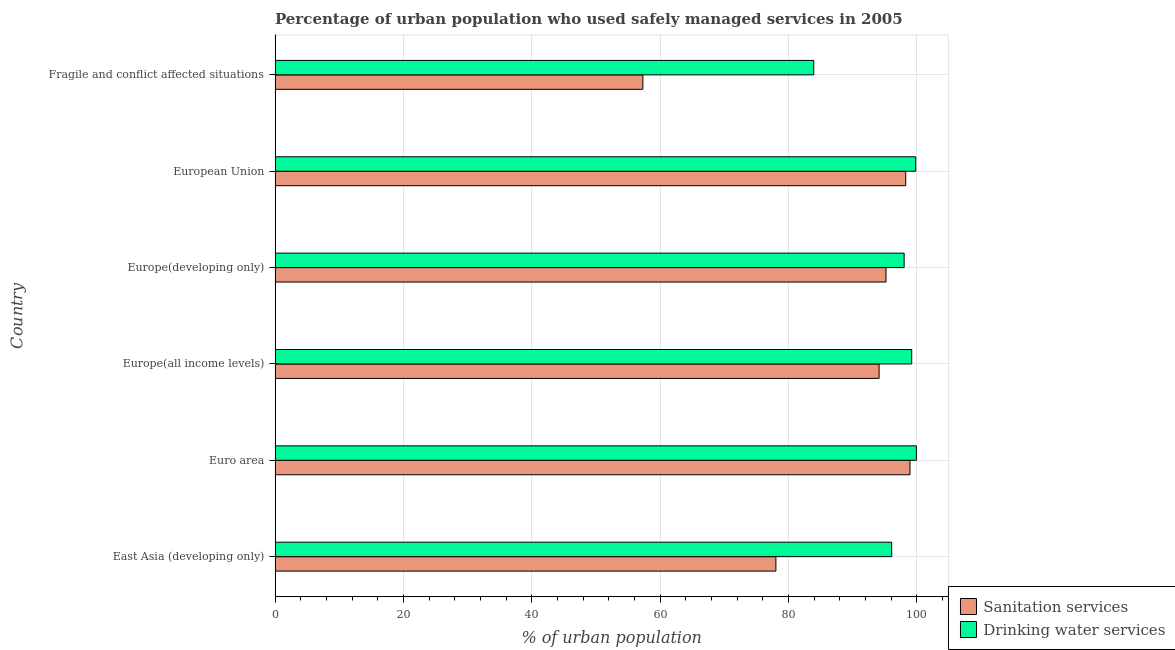How many different coloured bars are there?
Your response must be concise. 2. How many groups of bars are there?
Offer a terse response. 6. Are the number of bars per tick equal to the number of legend labels?
Make the answer very short. Yes. Are the number of bars on each tick of the Y-axis equal?
Your answer should be very brief. Yes. How many bars are there on the 6th tick from the top?
Offer a terse response. 2. How many bars are there on the 1st tick from the bottom?
Offer a very short reply. 2. What is the label of the 4th group of bars from the top?
Your answer should be very brief. Europe(all income levels). What is the percentage of urban population who used sanitation services in Euro area?
Provide a short and direct response. 98.92. Across all countries, what is the maximum percentage of urban population who used drinking water services?
Keep it short and to the point. 99.92. Across all countries, what is the minimum percentage of urban population who used drinking water services?
Ensure brevity in your answer.  83.92. In which country was the percentage of urban population who used sanitation services minimum?
Offer a terse response. Fragile and conflict affected situations. What is the total percentage of urban population who used sanitation services in the graph?
Keep it short and to the point. 521.79. What is the difference between the percentage of urban population who used drinking water services in East Asia (developing only) and that in European Union?
Ensure brevity in your answer.  -3.75. What is the difference between the percentage of urban population who used drinking water services in Europe(developing only) and the percentage of urban population who used sanitation services in European Union?
Ensure brevity in your answer.  -0.24. What is the average percentage of urban population who used drinking water services per country?
Ensure brevity in your answer.  96.15. What is the difference between the percentage of urban population who used sanitation services and percentage of urban population who used drinking water services in East Asia (developing only)?
Keep it short and to the point. -18.04. Is the percentage of urban population who used drinking water services in Europe(all income levels) less than that in Fragile and conflict affected situations?
Offer a terse response. No. What is the difference between the highest and the second highest percentage of urban population who used drinking water services?
Keep it short and to the point. 0.1. What is the difference between the highest and the lowest percentage of urban population who used sanitation services?
Your answer should be very brief. 41.62. In how many countries, is the percentage of urban population who used sanitation services greater than the average percentage of urban population who used sanitation services taken over all countries?
Ensure brevity in your answer.  4. What does the 1st bar from the top in East Asia (developing only) represents?
Make the answer very short. Drinking water services. What does the 2nd bar from the bottom in Euro area represents?
Your response must be concise. Drinking water services. Are all the bars in the graph horizontal?
Keep it short and to the point. Yes. What is the difference between two consecutive major ticks on the X-axis?
Make the answer very short. 20. Are the values on the major ticks of X-axis written in scientific E-notation?
Make the answer very short. No. Does the graph contain any zero values?
Give a very brief answer. No. How many legend labels are there?
Your answer should be very brief. 2. How are the legend labels stacked?
Ensure brevity in your answer.  Vertical. What is the title of the graph?
Your answer should be very brief. Percentage of urban population who used safely managed services in 2005. What is the label or title of the X-axis?
Provide a succinct answer. % of urban population. What is the label or title of the Y-axis?
Provide a short and direct response. Country. What is the % of urban population in Sanitation services in East Asia (developing only)?
Offer a very short reply. 78.03. What is the % of urban population of Drinking water services in East Asia (developing only)?
Ensure brevity in your answer.  96.07. What is the % of urban population of Sanitation services in Euro area?
Provide a short and direct response. 98.92. What is the % of urban population in Drinking water services in Euro area?
Offer a terse response. 99.92. What is the % of urban population in Sanitation services in Europe(all income levels)?
Provide a succinct answer. 94.11. What is the % of urban population of Drinking water services in Europe(all income levels)?
Give a very brief answer. 99.19. What is the % of urban population in Sanitation services in Europe(developing only)?
Ensure brevity in your answer.  95.18. What is the % of urban population of Drinking water services in Europe(developing only)?
Provide a succinct answer. 98.01. What is the % of urban population in Sanitation services in European Union?
Keep it short and to the point. 98.25. What is the % of urban population in Drinking water services in European Union?
Make the answer very short. 99.81. What is the % of urban population in Sanitation services in Fragile and conflict affected situations?
Give a very brief answer. 57.3. What is the % of urban population in Drinking water services in Fragile and conflict affected situations?
Offer a terse response. 83.92. Across all countries, what is the maximum % of urban population in Sanitation services?
Provide a succinct answer. 98.92. Across all countries, what is the maximum % of urban population of Drinking water services?
Provide a succinct answer. 99.92. Across all countries, what is the minimum % of urban population in Sanitation services?
Offer a terse response. 57.3. Across all countries, what is the minimum % of urban population of Drinking water services?
Provide a succinct answer. 83.92. What is the total % of urban population in Sanitation services in the graph?
Make the answer very short. 521.79. What is the total % of urban population of Drinking water services in the graph?
Ensure brevity in your answer.  576.92. What is the difference between the % of urban population of Sanitation services in East Asia (developing only) and that in Euro area?
Give a very brief answer. -20.89. What is the difference between the % of urban population in Drinking water services in East Asia (developing only) and that in Euro area?
Make the answer very short. -3.85. What is the difference between the % of urban population of Sanitation services in East Asia (developing only) and that in Europe(all income levels)?
Provide a short and direct response. -16.08. What is the difference between the % of urban population in Drinking water services in East Asia (developing only) and that in Europe(all income levels)?
Make the answer very short. -3.12. What is the difference between the % of urban population of Sanitation services in East Asia (developing only) and that in Europe(developing only)?
Offer a very short reply. -17.15. What is the difference between the % of urban population in Drinking water services in East Asia (developing only) and that in Europe(developing only)?
Make the answer very short. -1.94. What is the difference between the % of urban population of Sanitation services in East Asia (developing only) and that in European Union?
Offer a terse response. -20.22. What is the difference between the % of urban population in Drinking water services in East Asia (developing only) and that in European Union?
Provide a succinct answer. -3.75. What is the difference between the % of urban population in Sanitation services in East Asia (developing only) and that in Fragile and conflict affected situations?
Make the answer very short. 20.73. What is the difference between the % of urban population in Drinking water services in East Asia (developing only) and that in Fragile and conflict affected situations?
Your answer should be very brief. 12.15. What is the difference between the % of urban population of Sanitation services in Euro area and that in Europe(all income levels)?
Your answer should be very brief. 4.81. What is the difference between the % of urban population in Drinking water services in Euro area and that in Europe(all income levels)?
Keep it short and to the point. 0.73. What is the difference between the % of urban population in Sanitation services in Euro area and that in Europe(developing only)?
Your answer should be compact. 3.73. What is the difference between the % of urban population in Drinking water services in Euro area and that in Europe(developing only)?
Ensure brevity in your answer.  1.91. What is the difference between the % of urban population of Sanitation services in Euro area and that in European Union?
Give a very brief answer. 0.67. What is the difference between the % of urban population of Drinking water services in Euro area and that in European Union?
Make the answer very short. 0.1. What is the difference between the % of urban population in Sanitation services in Euro area and that in Fragile and conflict affected situations?
Keep it short and to the point. 41.62. What is the difference between the % of urban population in Drinking water services in Euro area and that in Fragile and conflict affected situations?
Your answer should be very brief. 15.99. What is the difference between the % of urban population of Sanitation services in Europe(all income levels) and that in Europe(developing only)?
Make the answer very short. -1.08. What is the difference between the % of urban population of Drinking water services in Europe(all income levels) and that in Europe(developing only)?
Offer a very short reply. 1.18. What is the difference between the % of urban population in Sanitation services in Europe(all income levels) and that in European Union?
Your answer should be compact. -4.14. What is the difference between the % of urban population in Drinking water services in Europe(all income levels) and that in European Union?
Your answer should be very brief. -0.63. What is the difference between the % of urban population in Sanitation services in Europe(all income levels) and that in Fragile and conflict affected situations?
Your answer should be very brief. 36.81. What is the difference between the % of urban population of Drinking water services in Europe(all income levels) and that in Fragile and conflict affected situations?
Ensure brevity in your answer.  15.26. What is the difference between the % of urban population in Sanitation services in Europe(developing only) and that in European Union?
Give a very brief answer. -3.07. What is the difference between the % of urban population in Drinking water services in Europe(developing only) and that in European Union?
Offer a terse response. -1.8. What is the difference between the % of urban population of Sanitation services in Europe(developing only) and that in Fragile and conflict affected situations?
Keep it short and to the point. 37.88. What is the difference between the % of urban population in Drinking water services in Europe(developing only) and that in Fragile and conflict affected situations?
Provide a succinct answer. 14.09. What is the difference between the % of urban population in Sanitation services in European Union and that in Fragile and conflict affected situations?
Your answer should be very brief. 40.95. What is the difference between the % of urban population in Drinking water services in European Union and that in Fragile and conflict affected situations?
Provide a short and direct response. 15.89. What is the difference between the % of urban population in Sanitation services in East Asia (developing only) and the % of urban population in Drinking water services in Euro area?
Provide a short and direct response. -21.89. What is the difference between the % of urban population of Sanitation services in East Asia (developing only) and the % of urban population of Drinking water services in Europe(all income levels)?
Make the answer very short. -21.16. What is the difference between the % of urban population in Sanitation services in East Asia (developing only) and the % of urban population in Drinking water services in Europe(developing only)?
Ensure brevity in your answer.  -19.98. What is the difference between the % of urban population in Sanitation services in East Asia (developing only) and the % of urban population in Drinking water services in European Union?
Your answer should be compact. -21.78. What is the difference between the % of urban population in Sanitation services in East Asia (developing only) and the % of urban population in Drinking water services in Fragile and conflict affected situations?
Make the answer very short. -5.89. What is the difference between the % of urban population in Sanitation services in Euro area and the % of urban population in Drinking water services in Europe(all income levels)?
Keep it short and to the point. -0.27. What is the difference between the % of urban population of Sanitation services in Euro area and the % of urban population of Drinking water services in European Union?
Provide a succinct answer. -0.9. What is the difference between the % of urban population in Sanitation services in Euro area and the % of urban population in Drinking water services in Fragile and conflict affected situations?
Offer a very short reply. 14.99. What is the difference between the % of urban population in Sanitation services in Europe(all income levels) and the % of urban population in Drinking water services in Europe(developing only)?
Provide a succinct answer. -3.9. What is the difference between the % of urban population in Sanitation services in Europe(all income levels) and the % of urban population in Drinking water services in European Union?
Keep it short and to the point. -5.71. What is the difference between the % of urban population of Sanitation services in Europe(all income levels) and the % of urban population of Drinking water services in Fragile and conflict affected situations?
Provide a succinct answer. 10.18. What is the difference between the % of urban population in Sanitation services in Europe(developing only) and the % of urban population in Drinking water services in European Union?
Ensure brevity in your answer.  -4.63. What is the difference between the % of urban population of Sanitation services in Europe(developing only) and the % of urban population of Drinking water services in Fragile and conflict affected situations?
Provide a short and direct response. 11.26. What is the difference between the % of urban population of Sanitation services in European Union and the % of urban population of Drinking water services in Fragile and conflict affected situations?
Offer a terse response. 14.33. What is the average % of urban population in Sanitation services per country?
Your answer should be compact. 86.96. What is the average % of urban population of Drinking water services per country?
Your answer should be compact. 96.15. What is the difference between the % of urban population in Sanitation services and % of urban population in Drinking water services in East Asia (developing only)?
Provide a short and direct response. -18.04. What is the difference between the % of urban population in Sanitation services and % of urban population in Drinking water services in Euro area?
Provide a short and direct response. -1. What is the difference between the % of urban population of Sanitation services and % of urban population of Drinking water services in Europe(all income levels)?
Offer a terse response. -5.08. What is the difference between the % of urban population of Sanitation services and % of urban population of Drinking water services in Europe(developing only)?
Offer a very short reply. -2.83. What is the difference between the % of urban population in Sanitation services and % of urban population in Drinking water services in European Union?
Ensure brevity in your answer.  -1.56. What is the difference between the % of urban population in Sanitation services and % of urban population in Drinking water services in Fragile and conflict affected situations?
Ensure brevity in your answer.  -26.62. What is the ratio of the % of urban population in Sanitation services in East Asia (developing only) to that in Euro area?
Make the answer very short. 0.79. What is the ratio of the % of urban population of Drinking water services in East Asia (developing only) to that in Euro area?
Your answer should be compact. 0.96. What is the ratio of the % of urban population in Sanitation services in East Asia (developing only) to that in Europe(all income levels)?
Give a very brief answer. 0.83. What is the ratio of the % of urban population in Drinking water services in East Asia (developing only) to that in Europe(all income levels)?
Offer a very short reply. 0.97. What is the ratio of the % of urban population of Sanitation services in East Asia (developing only) to that in Europe(developing only)?
Make the answer very short. 0.82. What is the ratio of the % of urban population in Drinking water services in East Asia (developing only) to that in Europe(developing only)?
Ensure brevity in your answer.  0.98. What is the ratio of the % of urban population in Sanitation services in East Asia (developing only) to that in European Union?
Keep it short and to the point. 0.79. What is the ratio of the % of urban population of Drinking water services in East Asia (developing only) to that in European Union?
Give a very brief answer. 0.96. What is the ratio of the % of urban population in Sanitation services in East Asia (developing only) to that in Fragile and conflict affected situations?
Your answer should be compact. 1.36. What is the ratio of the % of urban population in Drinking water services in East Asia (developing only) to that in Fragile and conflict affected situations?
Provide a succinct answer. 1.14. What is the ratio of the % of urban population of Sanitation services in Euro area to that in Europe(all income levels)?
Your answer should be compact. 1.05. What is the ratio of the % of urban population of Drinking water services in Euro area to that in Europe(all income levels)?
Offer a terse response. 1.01. What is the ratio of the % of urban population in Sanitation services in Euro area to that in Europe(developing only)?
Make the answer very short. 1.04. What is the ratio of the % of urban population in Drinking water services in Euro area to that in Europe(developing only)?
Keep it short and to the point. 1.02. What is the ratio of the % of urban population in Sanitation services in Euro area to that in European Union?
Offer a very short reply. 1.01. What is the ratio of the % of urban population in Sanitation services in Euro area to that in Fragile and conflict affected situations?
Offer a terse response. 1.73. What is the ratio of the % of urban population in Drinking water services in Euro area to that in Fragile and conflict affected situations?
Provide a succinct answer. 1.19. What is the ratio of the % of urban population in Sanitation services in Europe(all income levels) to that in Europe(developing only)?
Keep it short and to the point. 0.99. What is the ratio of the % of urban population of Sanitation services in Europe(all income levels) to that in European Union?
Your response must be concise. 0.96. What is the ratio of the % of urban population of Drinking water services in Europe(all income levels) to that in European Union?
Offer a very short reply. 0.99. What is the ratio of the % of urban population of Sanitation services in Europe(all income levels) to that in Fragile and conflict affected situations?
Keep it short and to the point. 1.64. What is the ratio of the % of urban population in Drinking water services in Europe(all income levels) to that in Fragile and conflict affected situations?
Provide a short and direct response. 1.18. What is the ratio of the % of urban population of Sanitation services in Europe(developing only) to that in European Union?
Your response must be concise. 0.97. What is the ratio of the % of urban population in Drinking water services in Europe(developing only) to that in European Union?
Your response must be concise. 0.98. What is the ratio of the % of urban population of Sanitation services in Europe(developing only) to that in Fragile and conflict affected situations?
Provide a short and direct response. 1.66. What is the ratio of the % of urban population in Drinking water services in Europe(developing only) to that in Fragile and conflict affected situations?
Offer a terse response. 1.17. What is the ratio of the % of urban population in Sanitation services in European Union to that in Fragile and conflict affected situations?
Your answer should be compact. 1.71. What is the ratio of the % of urban population in Drinking water services in European Union to that in Fragile and conflict affected situations?
Your response must be concise. 1.19. What is the difference between the highest and the second highest % of urban population of Sanitation services?
Provide a short and direct response. 0.67. What is the difference between the highest and the second highest % of urban population in Drinking water services?
Make the answer very short. 0.1. What is the difference between the highest and the lowest % of urban population of Sanitation services?
Offer a terse response. 41.62. What is the difference between the highest and the lowest % of urban population of Drinking water services?
Provide a succinct answer. 15.99. 